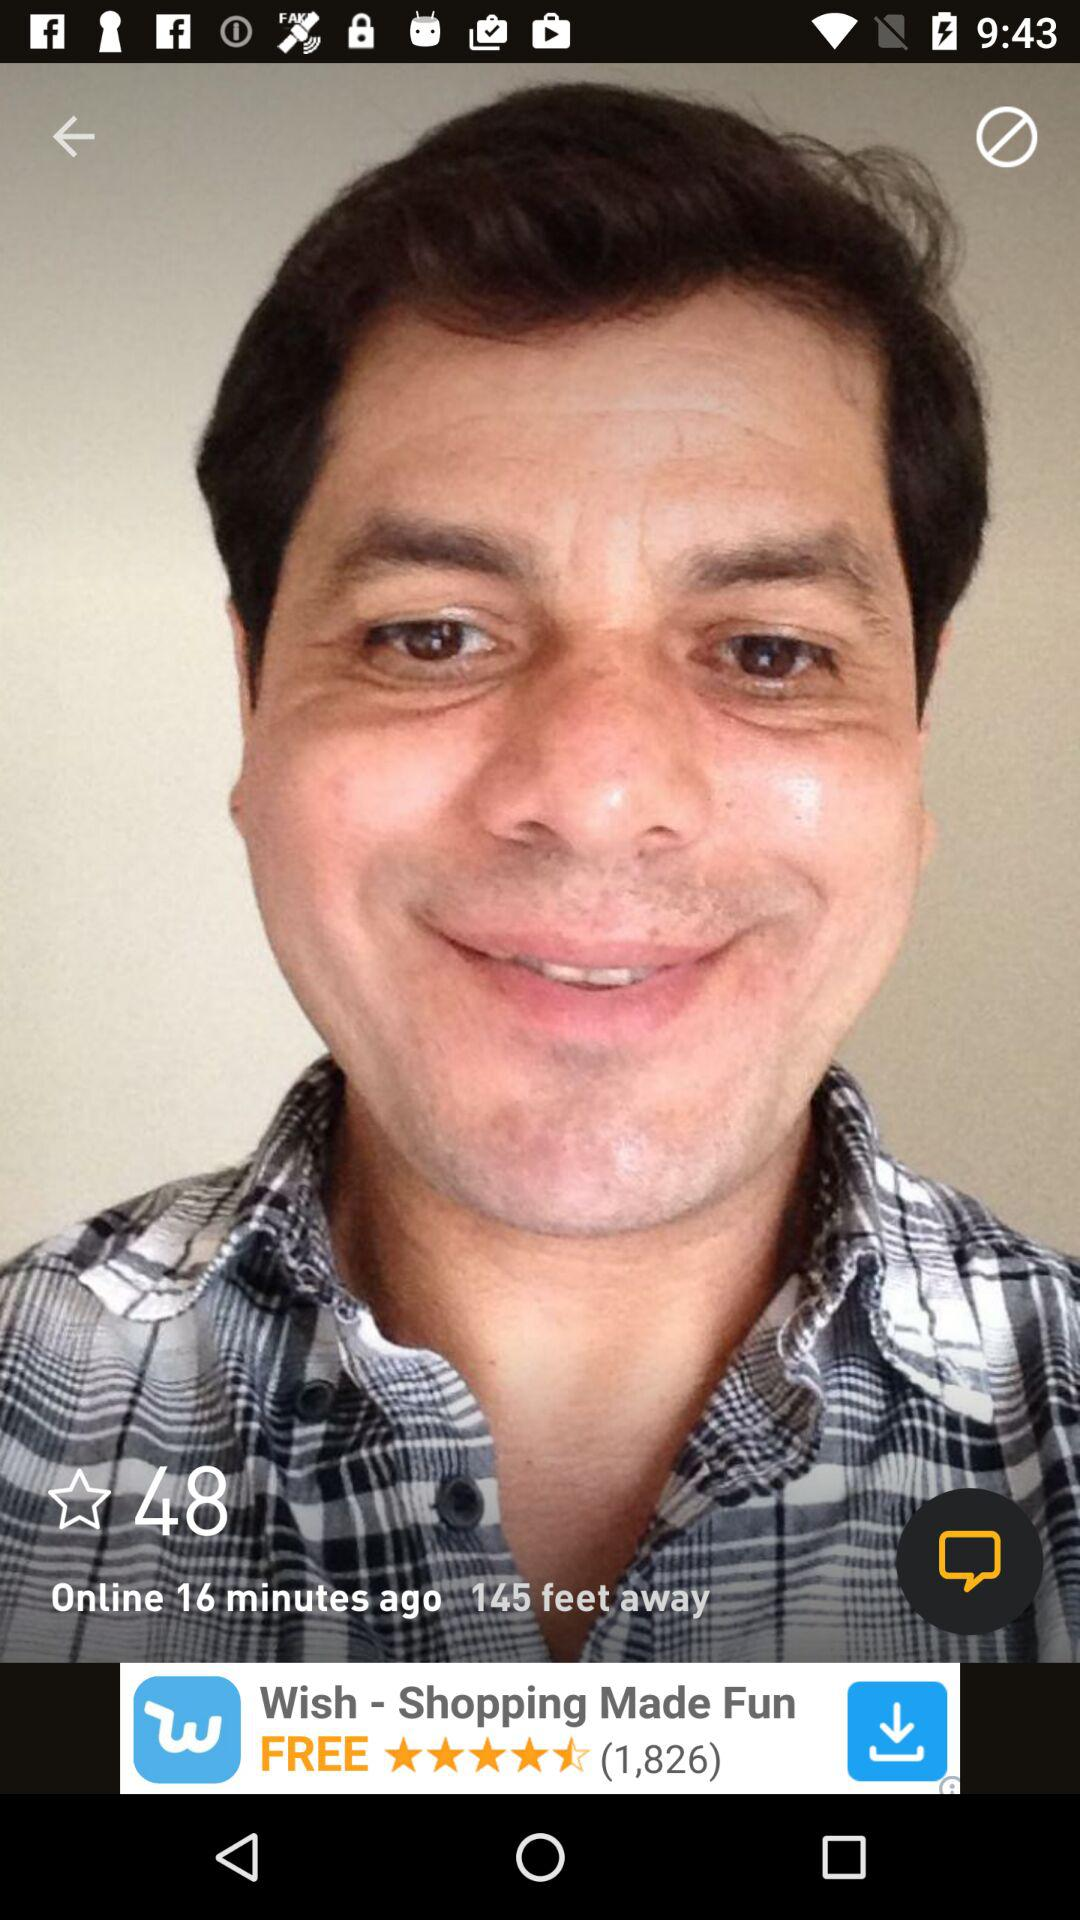How many feet away is the person?
Answer the question using a single word or phrase. 145 